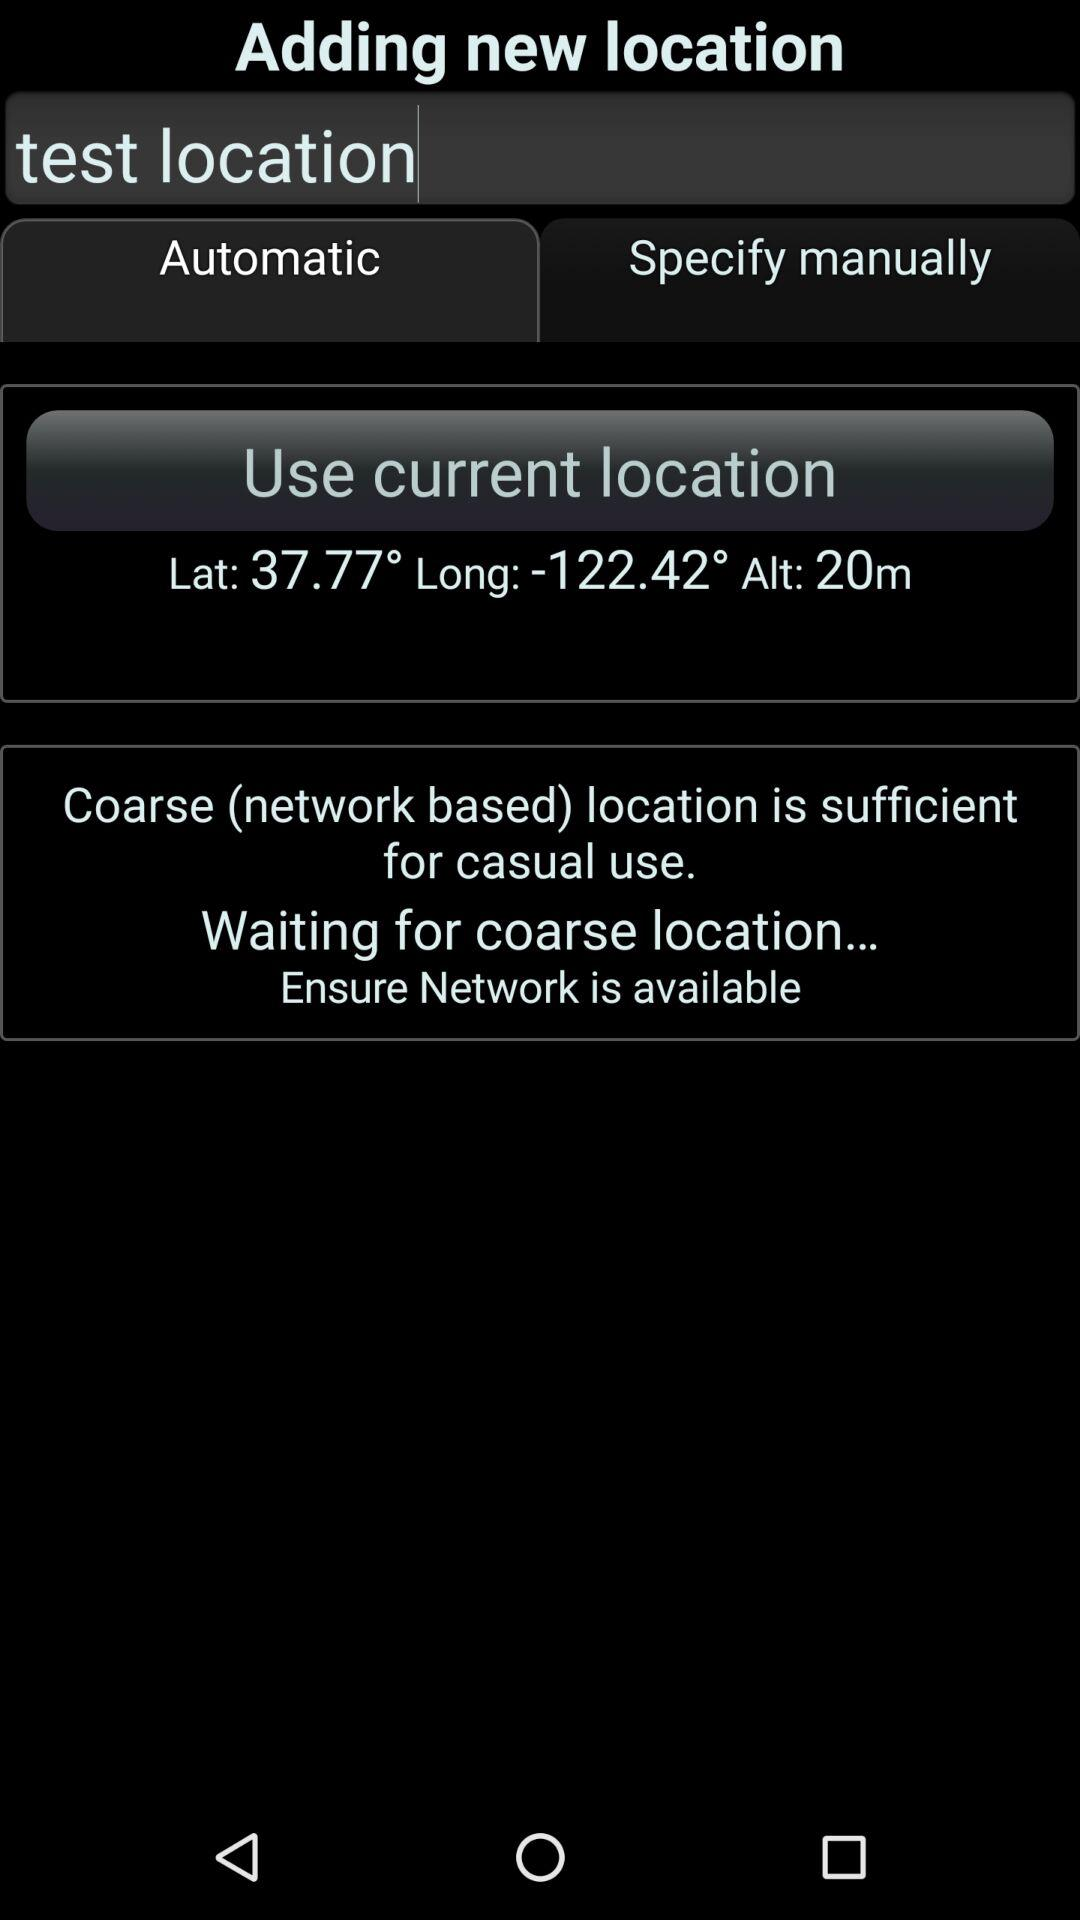What is current location?
When the provided information is insufficient, respond with <no answer>. <no answer> 